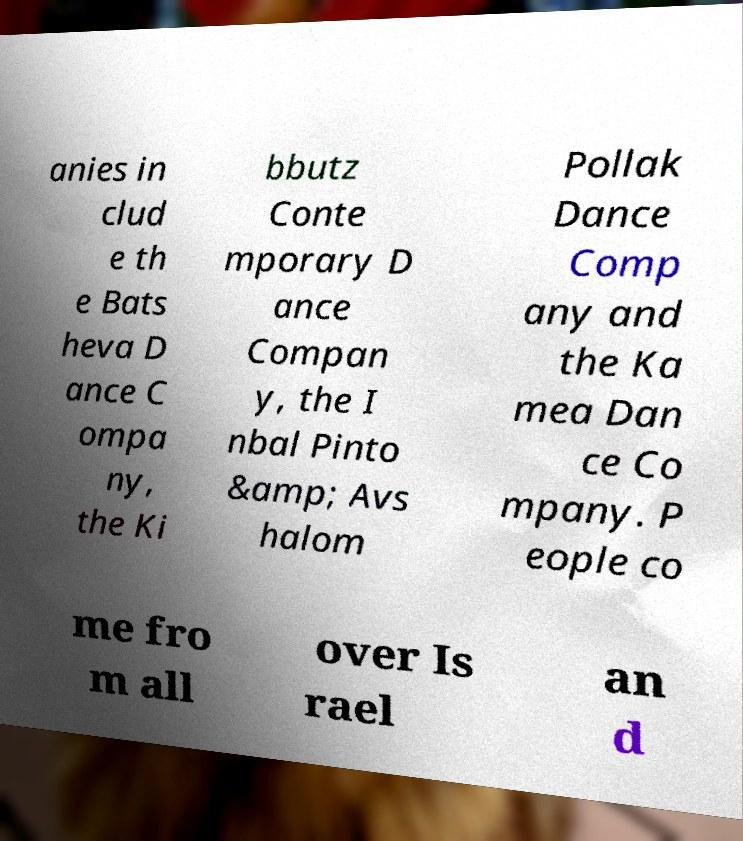For documentation purposes, I need the text within this image transcribed. Could you provide that? anies in clud e th e Bats heva D ance C ompa ny, the Ki bbutz Conte mporary D ance Compan y, the I nbal Pinto &amp; Avs halom Pollak Dance Comp any and the Ka mea Dan ce Co mpany. P eople co me fro m all over Is rael an d 